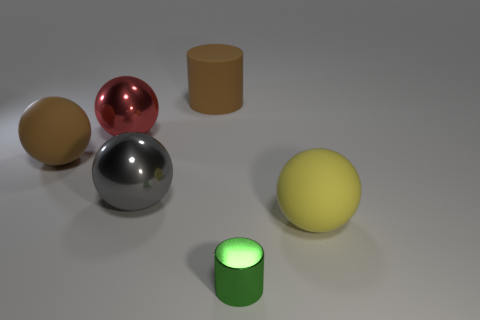There is a brown thing behind the brown rubber ball; does it have the same size as the large red metal sphere?
Provide a succinct answer. Yes. What color is the cylinder that is behind the matte ball that is on the left side of the ball to the right of the green cylinder?
Your answer should be compact. Brown. The big rubber cylinder has what color?
Give a very brief answer. Brown. Is the tiny shiny thing the same color as the large matte cylinder?
Offer a terse response. No. Does the yellow ball that is in front of the big matte cylinder have the same material as the large brown object that is to the left of the large red thing?
Keep it short and to the point. Yes. What is the material of the large red thing that is the same shape as the large yellow thing?
Provide a short and direct response. Metal. Is the big brown cylinder made of the same material as the green object?
Provide a succinct answer. No. What color is the shiny sphere behind the large rubber thing left of the matte cylinder?
Make the answer very short. Red. There is a red sphere that is made of the same material as the small green thing; what size is it?
Your answer should be very brief. Large. How many yellow objects have the same shape as the large red metal object?
Offer a very short reply. 1. 